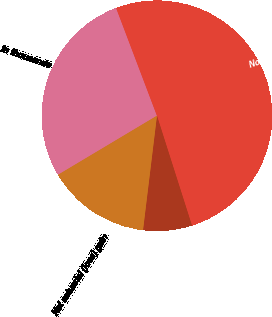<chart> <loc_0><loc_0><loc_500><loc_500><pie_chart><fcel>In thousands<fcel>Noncurrent liabilities<fcel>Prior service credit<fcel>Net actuarial (loss) gain<nl><fcel>27.8%<fcel>50.85%<fcel>6.84%<fcel>14.5%<nl></chart> 